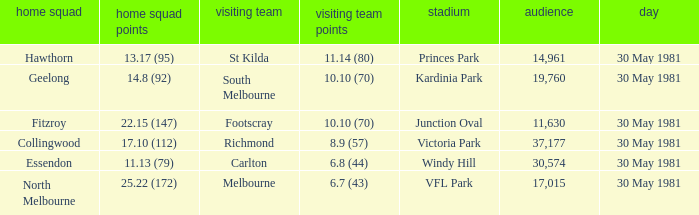What team played away at vfl park? Melbourne. 